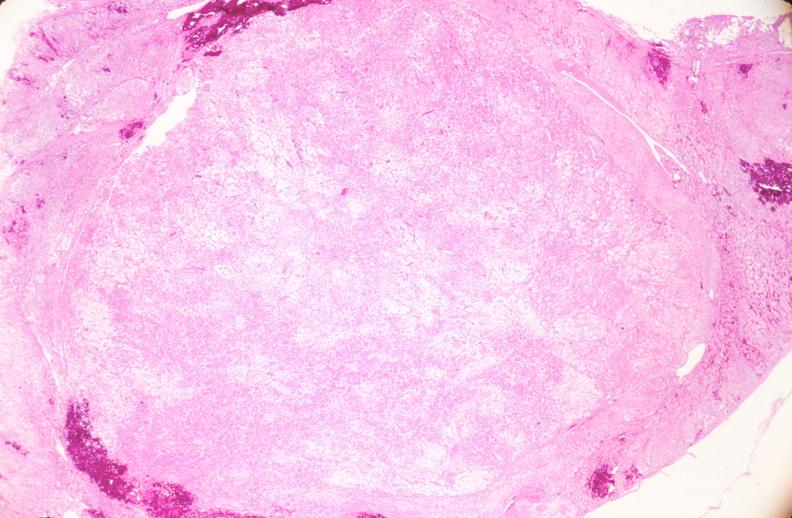where is this from?
Answer the question using a single word or phrase. Female reproductive system 